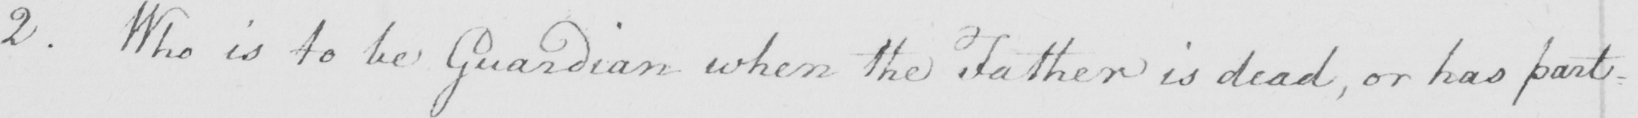What text is written in this handwritten line? 2 . Who is to be guardian when the Father is dead , or has part- 